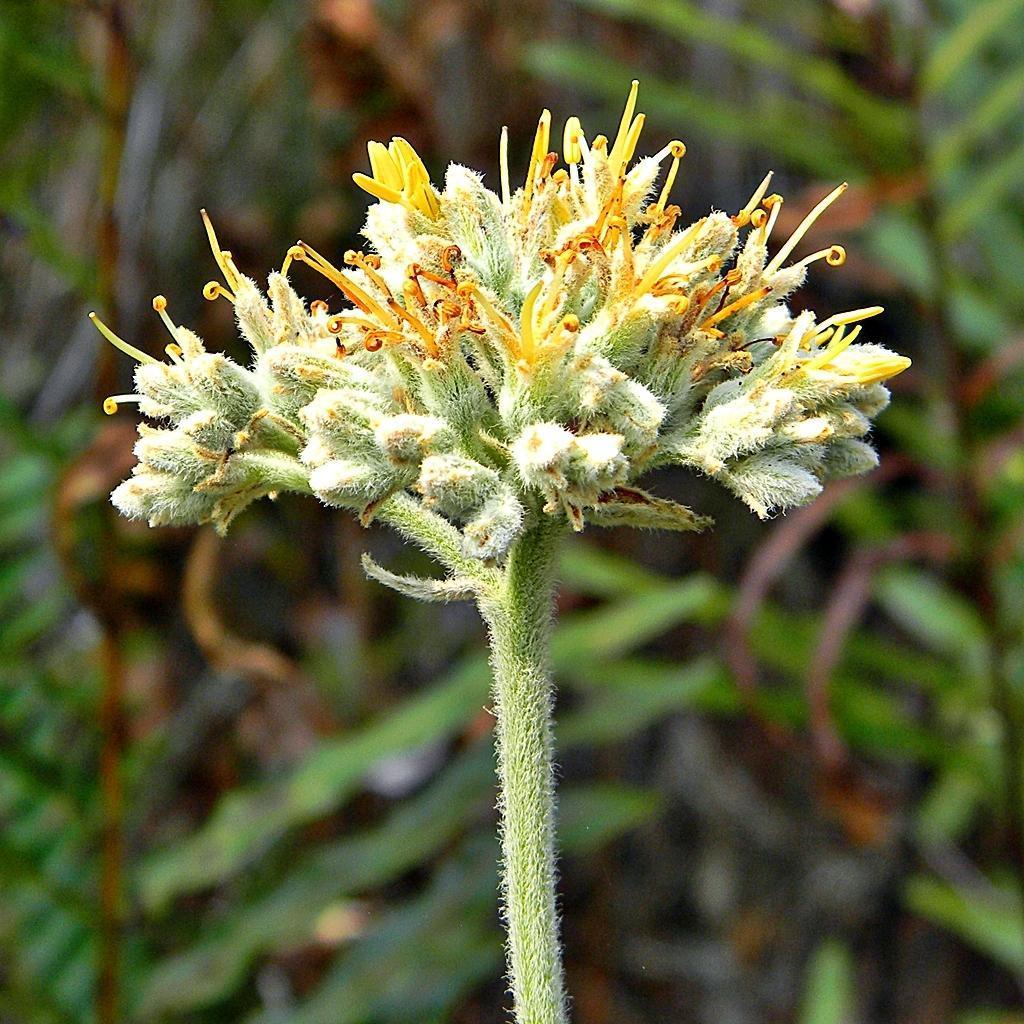How would you summarize this image in a sentence or two? In this image I can see green colour flower and number of yellow colour buds. I can also see this image is little bit blurry from background. 